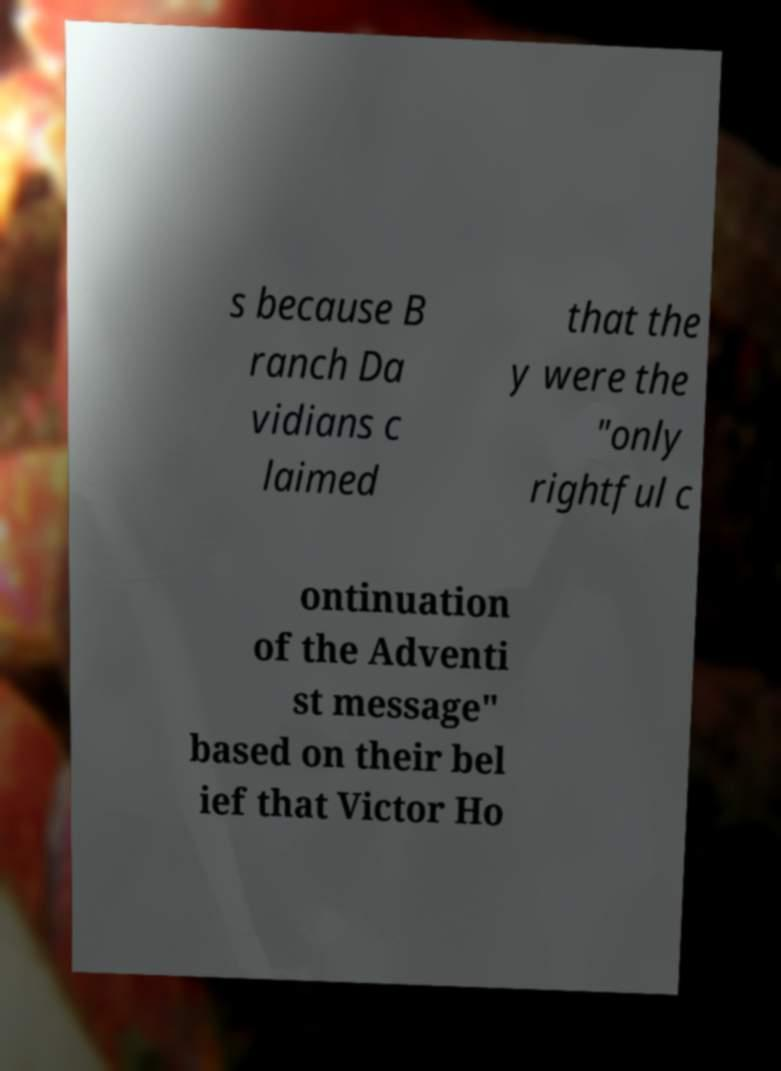Can you read and provide the text displayed in the image?This photo seems to have some interesting text. Can you extract and type it out for me? s because B ranch Da vidians c laimed that the y were the "only rightful c ontinuation of the Adventi st message" based on their bel ief that Victor Ho 